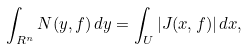Convert formula to latex. <formula><loc_0><loc_0><loc_500><loc_500>\int _ { R ^ { n } } N ( y , f ) \, d y = \int _ { U } | J ( x , f ) | \, d x ,</formula> 